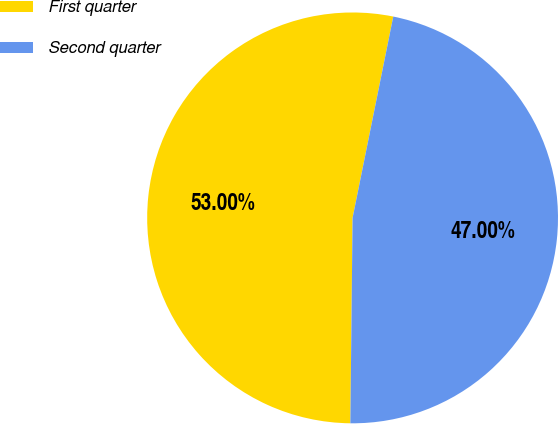<chart> <loc_0><loc_0><loc_500><loc_500><pie_chart><fcel>First quarter<fcel>Second quarter<nl><fcel>53.0%<fcel>47.0%<nl></chart> 